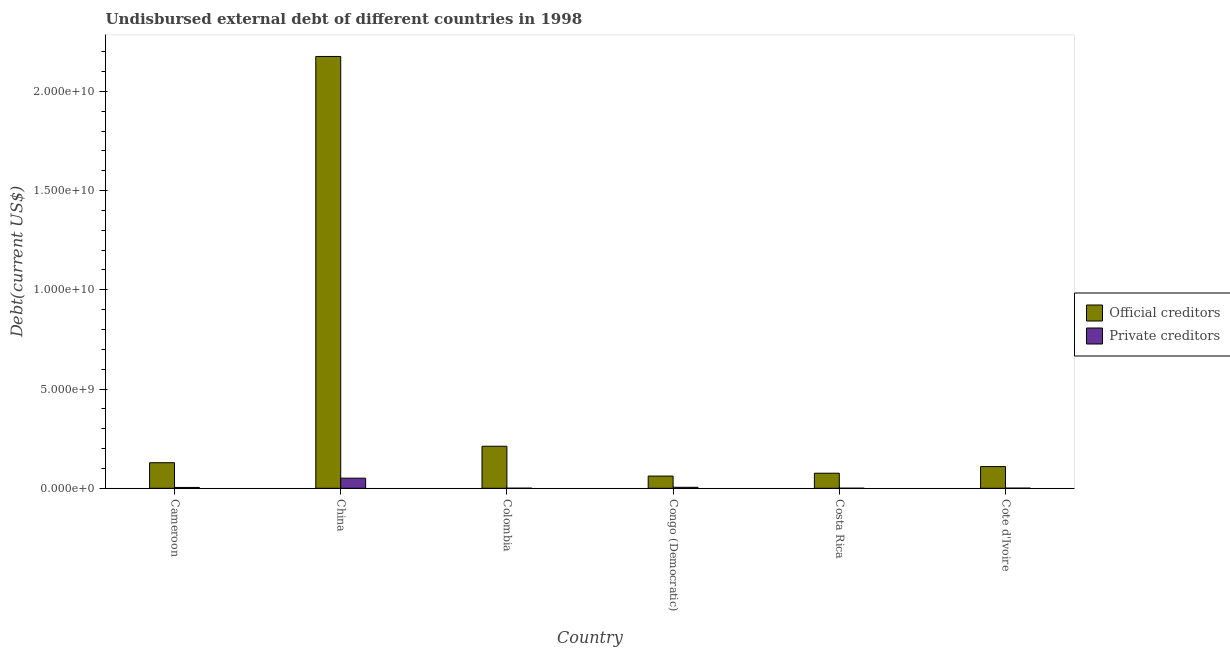How many different coloured bars are there?
Your answer should be compact. 2. How many groups of bars are there?
Keep it short and to the point. 6. Are the number of bars per tick equal to the number of legend labels?
Your answer should be compact. Yes. What is the label of the 1st group of bars from the left?
Keep it short and to the point. Cameroon. In how many cases, is the number of bars for a given country not equal to the number of legend labels?
Give a very brief answer. 0. What is the undisbursed external debt of private creditors in Cote d'Ivoire?
Keep it short and to the point. 6.89e+06. Across all countries, what is the maximum undisbursed external debt of official creditors?
Your answer should be compact. 2.18e+1. Across all countries, what is the minimum undisbursed external debt of private creditors?
Offer a terse response. 1.57e+06. In which country was the undisbursed external debt of private creditors maximum?
Keep it short and to the point. China. In which country was the undisbursed external debt of official creditors minimum?
Your answer should be very brief. Congo (Democratic). What is the total undisbursed external debt of official creditors in the graph?
Your response must be concise. 2.76e+1. What is the difference between the undisbursed external debt of private creditors in Congo (Democratic) and that in Costa Rica?
Keep it short and to the point. 4.76e+07. What is the difference between the undisbursed external debt of official creditors in Cameroon and the undisbursed external debt of private creditors in Congo (Democratic)?
Your answer should be very brief. 1.24e+09. What is the average undisbursed external debt of private creditors per country?
Your answer should be compact. 1.02e+08. What is the difference between the undisbursed external debt of official creditors and undisbursed external debt of private creditors in Cameroon?
Your answer should be very brief. 1.25e+09. What is the ratio of the undisbursed external debt of official creditors in China to that in Cote d'Ivoire?
Offer a very short reply. 19.89. Is the difference between the undisbursed external debt of official creditors in China and Costa Rica greater than the difference between the undisbursed external debt of private creditors in China and Costa Rica?
Provide a short and direct response. Yes. What is the difference between the highest and the second highest undisbursed external debt of official creditors?
Your answer should be compact. 1.96e+1. What is the difference between the highest and the lowest undisbursed external debt of official creditors?
Keep it short and to the point. 2.11e+1. What does the 2nd bar from the left in China represents?
Ensure brevity in your answer.  Private creditors. What does the 1st bar from the right in Cameroon represents?
Offer a terse response. Private creditors. Does the graph contain any zero values?
Provide a succinct answer. No. Does the graph contain grids?
Your response must be concise. No. Where does the legend appear in the graph?
Provide a succinct answer. Center right. How many legend labels are there?
Ensure brevity in your answer.  2. What is the title of the graph?
Make the answer very short. Undisbursed external debt of different countries in 1998. What is the label or title of the X-axis?
Offer a very short reply. Country. What is the label or title of the Y-axis?
Give a very brief answer. Debt(current US$). What is the Debt(current US$) of Official creditors in Cameroon?
Offer a very short reply. 1.29e+09. What is the Debt(current US$) of Private creditors in Cameroon?
Give a very brief answer. 4.18e+07. What is the Debt(current US$) of Official creditors in China?
Your answer should be compact. 2.18e+1. What is the Debt(current US$) in Private creditors in China?
Keep it short and to the point. 5.09e+08. What is the Debt(current US$) in Official creditors in Colombia?
Ensure brevity in your answer.  2.12e+09. What is the Debt(current US$) of Private creditors in Colombia?
Offer a very short reply. 3.28e+06. What is the Debt(current US$) of Official creditors in Congo (Democratic)?
Offer a terse response. 6.15e+08. What is the Debt(current US$) in Private creditors in Congo (Democratic)?
Provide a short and direct response. 4.92e+07. What is the Debt(current US$) in Official creditors in Costa Rica?
Offer a terse response. 7.60e+08. What is the Debt(current US$) of Private creditors in Costa Rica?
Provide a short and direct response. 1.57e+06. What is the Debt(current US$) of Official creditors in Cote d'Ivoire?
Your answer should be compact. 1.09e+09. What is the Debt(current US$) in Private creditors in Cote d'Ivoire?
Ensure brevity in your answer.  6.89e+06. Across all countries, what is the maximum Debt(current US$) in Official creditors?
Ensure brevity in your answer.  2.18e+1. Across all countries, what is the maximum Debt(current US$) of Private creditors?
Give a very brief answer. 5.09e+08. Across all countries, what is the minimum Debt(current US$) of Official creditors?
Give a very brief answer. 6.15e+08. Across all countries, what is the minimum Debt(current US$) of Private creditors?
Provide a short and direct response. 1.57e+06. What is the total Debt(current US$) of Official creditors in the graph?
Keep it short and to the point. 2.76e+1. What is the total Debt(current US$) in Private creditors in the graph?
Keep it short and to the point. 6.12e+08. What is the difference between the Debt(current US$) in Official creditors in Cameroon and that in China?
Keep it short and to the point. -2.05e+1. What is the difference between the Debt(current US$) of Private creditors in Cameroon and that in China?
Ensure brevity in your answer.  -4.68e+08. What is the difference between the Debt(current US$) in Official creditors in Cameroon and that in Colombia?
Offer a very short reply. -8.30e+08. What is the difference between the Debt(current US$) in Private creditors in Cameroon and that in Colombia?
Your answer should be very brief. 3.85e+07. What is the difference between the Debt(current US$) in Official creditors in Cameroon and that in Congo (Democratic)?
Provide a short and direct response. 6.73e+08. What is the difference between the Debt(current US$) in Private creditors in Cameroon and that in Congo (Democratic)?
Offer a terse response. -7.34e+06. What is the difference between the Debt(current US$) of Official creditors in Cameroon and that in Costa Rica?
Give a very brief answer. 5.28e+08. What is the difference between the Debt(current US$) of Private creditors in Cameroon and that in Costa Rica?
Provide a succinct answer. 4.02e+07. What is the difference between the Debt(current US$) in Official creditors in Cameroon and that in Cote d'Ivoire?
Your response must be concise. 1.94e+08. What is the difference between the Debt(current US$) of Private creditors in Cameroon and that in Cote d'Ivoire?
Offer a terse response. 3.49e+07. What is the difference between the Debt(current US$) of Official creditors in China and that in Colombia?
Give a very brief answer. 1.96e+1. What is the difference between the Debt(current US$) of Private creditors in China and that in Colombia?
Make the answer very short. 5.06e+08. What is the difference between the Debt(current US$) in Official creditors in China and that in Congo (Democratic)?
Offer a terse response. 2.11e+1. What is the difference between the Debt(current US$) of Private creditors in China and that in Congo (Democratic)?
Your answer should be compact. 4.60e+08. What is the difference between the Debt(current US$) of Official creditors in China and that in Costa Rica?
Keep it short and to the point. 2.10e+1. What is the difference between the Debt(current US$) in Private creditors in China and that in Costa Rica?
Offer a very short reply. 5.08e+08. What is the difference between the Debt(current US$) of Official creditors in China and that in Cote d'Ivoire?
Give a very brief answer. 2.07e+1. What is the difference between the Debt(current US$) of Private creditors in China and that in Cote d'Ivoire?
Provide a short and direct response. 5.03e+08. What is the difference between the Debt(current US$) of Official creditors in Colombia and that in Congo (Democratic)?
Your response must be concise. 1.50e+09. What is the difference between the Debt(current US$) of Private creditors in Colombia and that in Congo (Democratic)?
Your answer should be very brief. -4.59e+07. What is the difference between the Debt(current US$) of Official creditors in Colombia and that in Costa Rica?
Your answer should be compact. 1.36e+09. What is the difference between the Debt(current US$) of Private creditors in Colombia and that in Costa Rica?
Offer a terse response. 1.71e+06. What is the difference between the Debt(current US$) in Official creditors in Colombia and that in Cote d'Ivoire?
Give a very brief answer. 1.02e+09. What is the difference between the Debt(current US$) of Private creditors in Colombia and that in Cote d'Ivoire?
Offer a very short reply. -3.61e+06. What is the difference between the Debt(current US$) of Official creditors in Congo (Democratic) and that in Costa Rica?
Offer a very short reply. -1.45e+08. What is the difference between the Debt(current US$) in Private creditors in Congo (Democratic) and that in Costa Rica?
Give a very brief answer. 4.76e+07. What is the difference between the Debt(current US$) in Official creditors in Congo (Democratic) and that in Cote d'Ivoire?
Provide a succinct answer. -4.79e+08. What is the difference between the Debt(current US$) in Private creditors in Congo (Democratic) and that in Cote d'Ivoire?
Provide a succinct answer. 4.23e+07. What is the difference between the Debt(current US$) in Official creditors in Costa Rica and that in Cote d'Ivoire?
Keep it short and to the point. -3.34e+08. What is the difference between the Debt(current US$) in Private creditors in Costa Rica and that in Cote d'Ivoire?
Offer a terse response. -5.32e+06. What is the difference between the Debt(current US$) of Official creditors in Cameroon and the Debt(current US$) of Private creditors in China?
Give a very brief answer. 7.78e+08. What is the difference between the Debt(current US$) in Official creditors in Cameroon and the Debt(current US$) in Private creditors in Colombia?
Keep it short and to the point. 1.28e+09. What is the difference between the Debt(current US$) of Official creditors in Cameroon and the Debt(current US$) of Private creditors in Congo (Democratic)?
Keep it short and to the point. 1.24e+09. What is the difference between the Debt(current US$) of Official creditors in Cameroon and the Debt(current US$) of Private creditors in Costa Rica?
Provide a succinct answer. 1.29e+09. What is the difference between the Debt(current US$) in Official creditors in Cameroon and the Debt(current US$) in Private creditors in Cote d'Ivoire?
Provide a short and direct response. 1.28e+09. What is the difference between the Debt(current US$) of Official creditors in China and the Debt(current US$) of Private creditors in Colombia?
Provide a short and direct response. 2.18e+1. What is the difference between the Debt(current US$) of Official creditors in China and the Debt(current US$) of Private creditors in Congo (Democratic)?
Make the answer very short. 2.17e+1. What is the difference between the Debt(current US$) of Official creditors in China and the Debt(current US$) of Private creditors in Costa Rica?
Keep it short and to the point. 2.18e+1. What is the difference between the Debt(current US$) in Official creditors in China and the Debt(current US$) in Private creditors in Cote d'Ivoire?
Make the answer very short. 2.17e+1. What is the difference between the Debt(current US$) of Official creditors in Colombia and the Debt(current US$) of Private creditors in Congo (Democratic)?
Provide a succinct answer. 2.07e+09. What is the difference between the Debt(current US$) in Official creditors in Colombia and the Debt(current US$) in Private creditors in Costa Rica?
Your answer should be very brief. 2.12e+09. What is the difference between the Debt(current US$) of Official creditors in Colombia and the Debt(current US$) of Private creditors in Cote d'Ivoire?
Ensure brevity in your answer.  2.11e+09. What is the difference between the Debt(current US$) of Official creditors in Congo (Democratic) and the Debt(current US$) of Private creditors in Costa Rica?
Give a very brief answer. 6.13e+08. What is the difference between the Debt(current US$) in Official creditors in Congo (Democratic) and the Debt(current US$) in Private creditors in Cote d'Ivoire?
Offer a terse response. 6.08e+08. What is the difference between the Debt(current US$) of Official creditors in Costa Rica and the Debt(current US$) of Private creditors in Cote d'Ivoire?
Offer a terse response. 7.53e+08. What is the average Debt(current US$) of Official creditors per country?
Ensure brevity in your answer.  4.60e+09. What is the average Debt(current US$) of Private creditors per country?
Keep it short and to the point. 1.02e+08. What is the difference between the Debt(current US$) in Official creditors and Debt(current US$) in Private creditors in Cameroon?
Provide a succinct answer. 1.25e+09. What is the difference between the Debt(current US$) of Official creditors and Debt(current US$) of Private creditors in China?
Provide a succinct answer. 2.12e+1. What is the difference between the Debt(current US$) of Official creditors and Debt(current US$) of Private creditors in Colombia?
Keep it short and to the point. 2.11e+09. What is the difference between the Debt(current US$) in Official creditors and Debt(current US$) in Private creditors in Congo (Democratic)?
Your response must be concise. 5.65e+08. What is the difference between the Debt(current US$) of Official creditors and Debt(current US$) of Private creditors in Costa Rica?
Provide a succinct answer. 7.58e+08. What is the difference between the Debt(current US$) in Official creditors and Debt(current US$) in Private creditors in Cote d'Ivoire?
Your answer should be very brief. 1.09e+09. What is the ratio of the Debt(current US$) of Official creditors in Cameroon to that in China?
Keep it short and to the point. 0.06. What is the ratio of the Debt(current US$) in Private creditors in Cameroon to that in China?
Keep it short and to the point. 0.08. What is the ratio of the Debt(current US$) in Official creditors in Cameroon to that in Colombia?
Provide a short and direct response. 0.61. What is the ratio of the Debt(current US$) of Private creditors in Cameroon to that in Colombia?
Your response must be concise. 12.74. What is the ratio of the Debt(current US$) of Official creditors in Cameroon to that in Congo (Democratic)?
Make the answer very short. 2.1. What is the ratio of the Debt(current US$) in Private creditors in Cameroon to that in Congo (Democratic)?
Offer a terse response. 0.85. What is the ratio of the Debt(current US$) in Official creditors in Cameroon to that in Costa Rica?
Provide a succinct answer. 1.7. What is the ratio of the Debt(current US$) of Private creditors in Cameroon to that in Costa Rica?
Give a very brief answer. 26.67. What is the ratio of the Debt(current US$) in Official creditors in Cameroon to that in Cote d'Ivoire?
Offer a terse response. 1.18. What is the ratio of the Debt(current US$) in Private creditors in Cameroon to that in Cote d'Ivoire?
Keep it short and to the point. 6.07. What is the ratio of the Debt(current US$) in Official creditors in China to that in Colombia?
Offer a very short reply. 10.27. What is the ratio of the Debt(current US$) in Private creditors in China to that in Colombia?
Provide a short and direct response. 155.28. What is the ratio of the Debt(current US$) in Official creditors in China to that in Congo (Democratic)?
Provide a succinct answer. 35.4. What is the ratio of the Debt(current US$) of Private creditors in China to that in Congo (Democratic)?
Give a very brief answer. 10.36. What is the ratio of the Debt(current US$) in Official creditors in China to that in Costa Rica?
Offer a very short reply. 28.64. What is the ratio of the Debt(current US$) in Private creditors in China to that in Costa Rica?
Your response must be concise. 324.91. What is the ratio of the Debt(current US$) in Official creditors in China to that in Cote d'Ivoire?
Your answer should be very brief. 19.89. What is the ratio of the Debt(current US$) of Private creditors in China to that in Cote d'Ivoire?
Make the answer very short. 73.97. What is the ratio of the Debt(current US$) in Official creditors in Colombia to that in Congo (Democratic)?
Provide a succinct answer. 3.45. What is the ratio of the Debt(current US$) in Private creditors in Colombia to that in Congo (Democratic)?
Provide a succinct answer. 0.07. What is the ratio of the Debt(current US$) of Official creditors in Colombia to that in Costa Rica?
Make the answer very short. 2.79. What is the ratio of the Debt(current US$) of Private creditors in Colombia to that in Costa Rica?
Your answer should be very brief. 2.09. What is the ratio of the Debt(current US$) of Official creditors in Colombia to that in Cote d'Ivoire?
Provide a succinct answer. 1.94. What is the ratio of the Debt(current US$) in Private creditors in Colombia to that in Cote d'Ivoire?
Keep it short and to the point. 0.48. What is the ratio of the Debt(current US$) of Official creditors in Congo (Democratic) to that in Costa Rica?
Your answer should be very brief. 0.81. What is the ratio of the Debt(current US$) in Private creditors in Congo (Democratic) to that in Costa Rica?
Give a very brief answer. 31.35. What is the ratio of the Debt(current US$) of Official creditors in Congo (Democratic) to that in Cote d'Ivoire?
Provide a succinct answer. 0.56. What is the ratio of the Debt(current US$) of Private creditors in Congo (Democratic) to that in Cote d'Ivoire?
Your answer should be compact. 7.14. What is the ratio of the Debt(current US$) of Official creditors in Costa Rica to that in Cote d'Ivoire?
Give a very brief answer. 0.69. What is the ratio of the Debt(current US$) in Private creditors in Costa Rica to that in Cote d'Ivoire?
Provide a short and direct response. 0.23. What is the difference between the highest and the second highest Debt(current US$) of Official creditors?
Keep it short and to the point. 1.96e+1. What is the difference between the highest and the second highest Debt(current US$) in Private creditors?
Provide a short and direct response. 4.60e+08. What is the difference between the highest and the lowest Debt(current US$) in Official creditors?
Your answer should be very brief. 2.11e+1. What is the difference between the highest and the lowest Debt(current US$) of Private creditors?
Make the answer very short. 5.08e+08. 